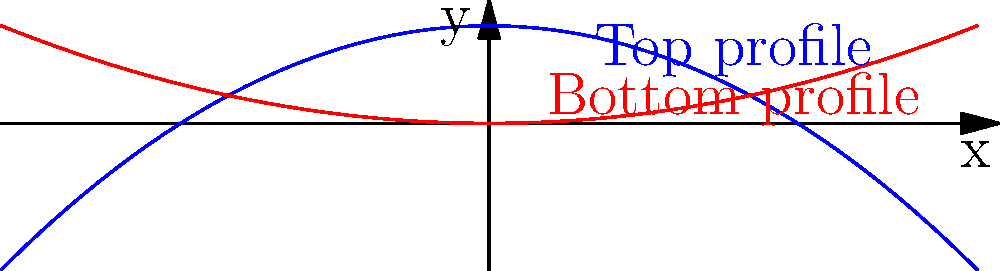In designing a futuristic car, you're tasked with plotting its aerodynamic profile using parabolic equations. The top profile of the car is given by the equation $y = -0.05x^2 + 2$, and the bottom profile is given by $y = 0.02x^2$. What is the maximum width of the car body between $x = -10$ and $x = 10$, and at what $x$-coordinate does this occur? To find the maximum width of the car body, we need to follow these steps:

1) The width at any point is the difference between the top and bottom profiles:
   $W(x) = (-0.05x^2 + 2) - (0.02x^2) = -0.07x^2 + 2$

2) To find the maximum width, we need to find where the derivative of W(x) is zero:
   $W'(x) = -0.14x$

3) Setting this to zero:
   $-0.14x = 0$
   $x = 0$

4) The second derivative $W''(x) = -0.14$ is negative, confirming this is a maximum.

5) The maximum width occurs at $x = 0$, where:
   $W(0) = -0.07(0)^2 + 2 = 2$

Therefore, the maximum width is 2 units and occurs at $x = 0$.
Answer: Maximum width: 2 units; occurs at $x = 0$ 